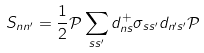<formula> <loc_0><loc_0><loc_500><loc_500>S _ { n n ^ { \prime } } = \frac { 1 } { 2 } \mathcal { P } \sum _ { s s ^ { \prime } } d _ { n s } ^ { + } \sigma _ { s s ^ { \prime } } d _ { n ^ { \prime } s ^ { \prime } } \mathcal { P }</formula> 